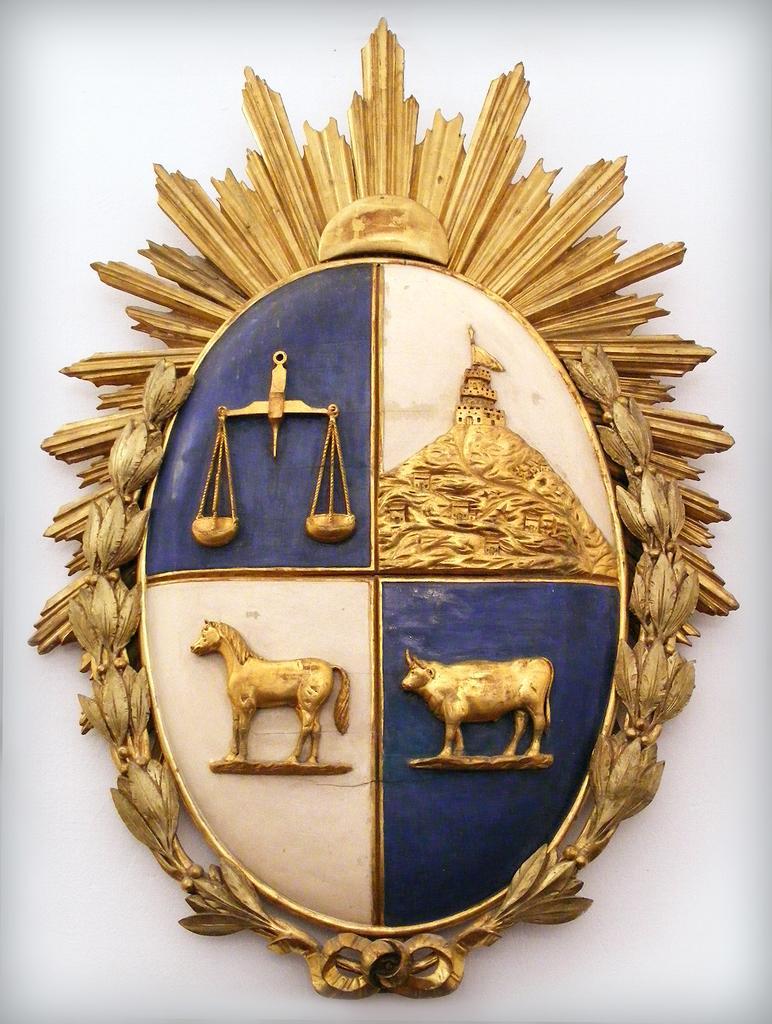What can be seen on the wall in the image? There is a wall decor in the image. Where is the wall decor located in the image? The wall decor is placed on a wall. How many cakes are stacked on top of the wall decor in the image? There are no cakes present in the image. What part of the stem is visible in the image? There is no stem present in the image. 